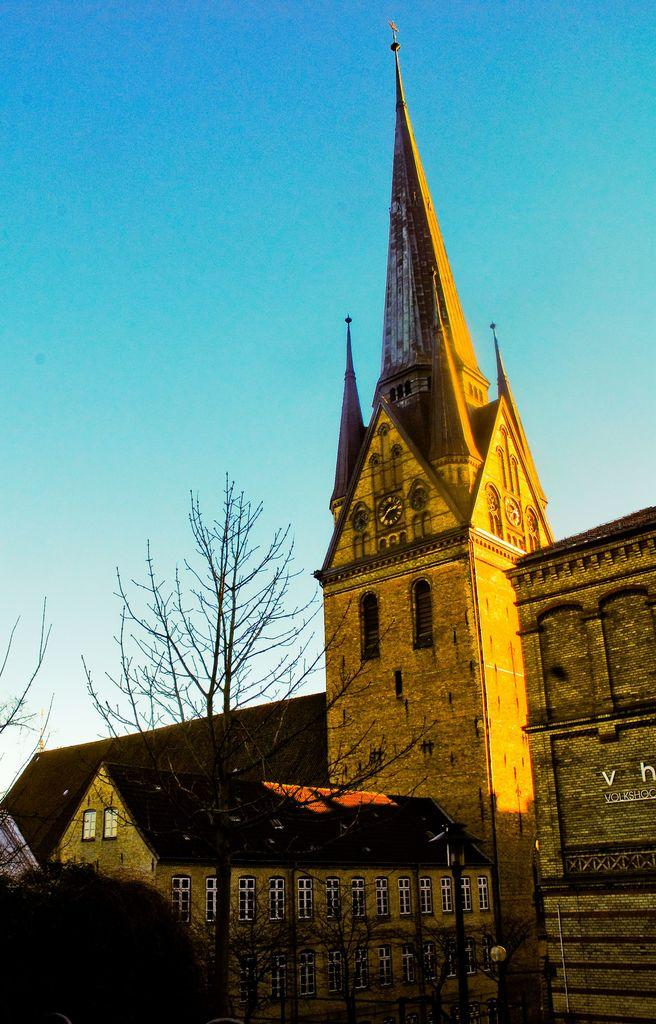What is the main subject in the center of the image? There is a building in the center of the image. What type of vegetation is present at the bottom of the image? There are trees at the bottom of the image. What can be seen in the background of the image? The sky is visible in the background of the image. What type of secretary is working in the building in the image? There is no indication of a secretary or any people working in the building in the image. 